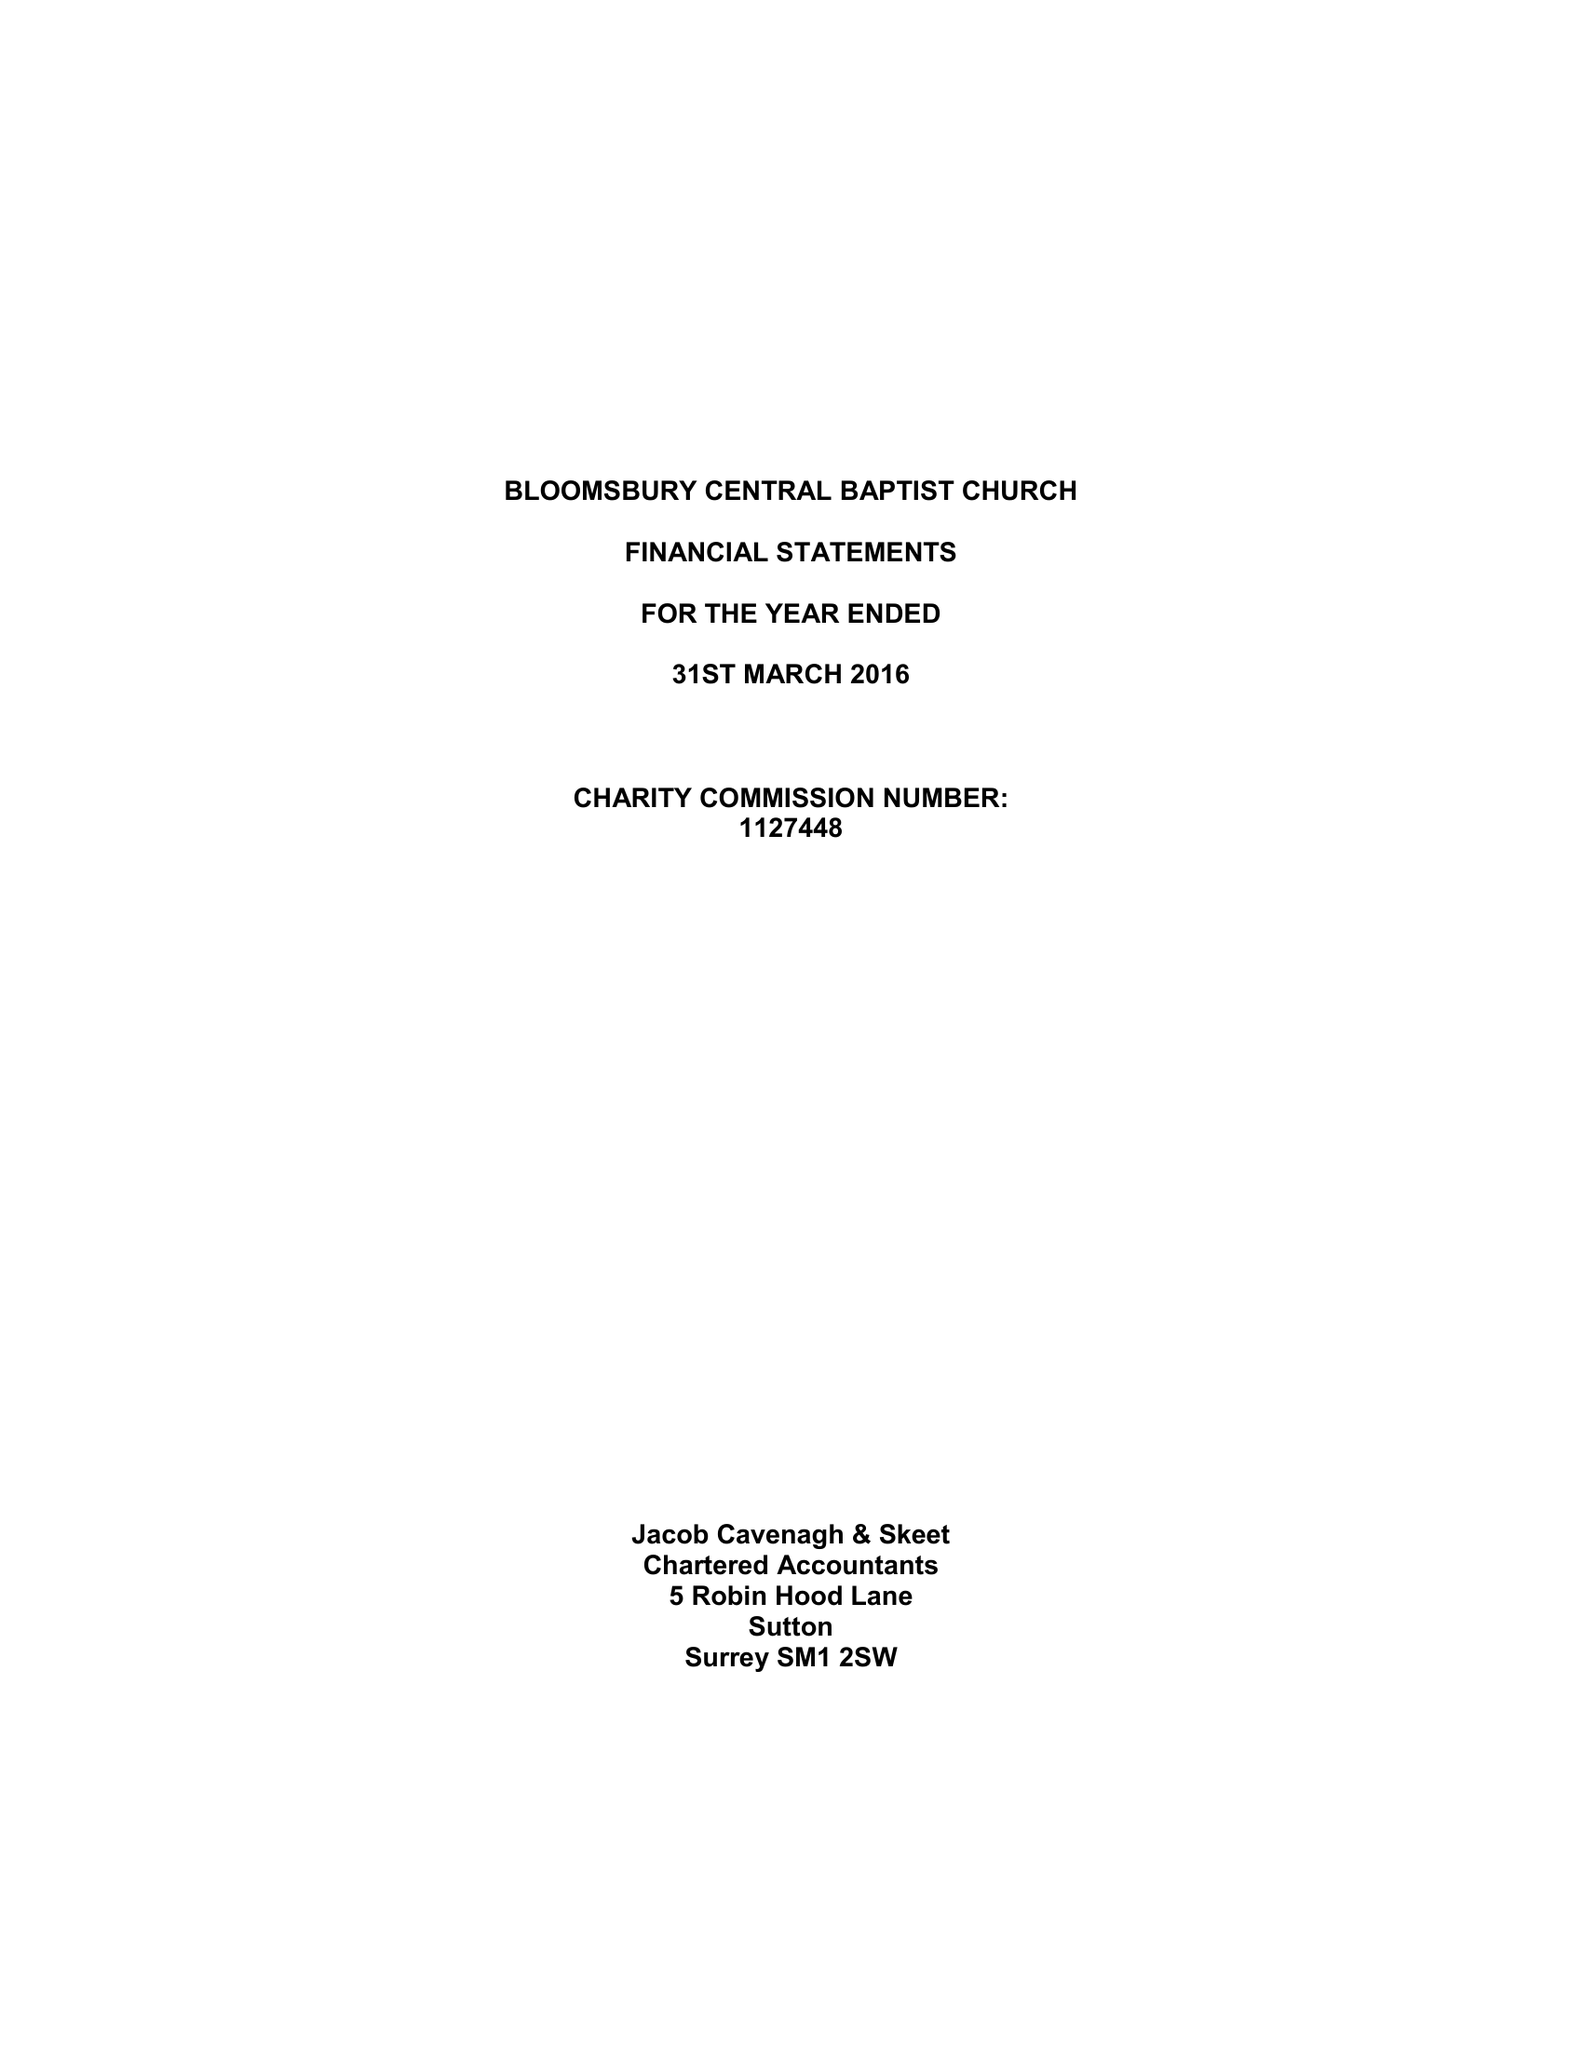What is the value for the address__post_town?
Answer the question using a single word or phrase. LONDON 